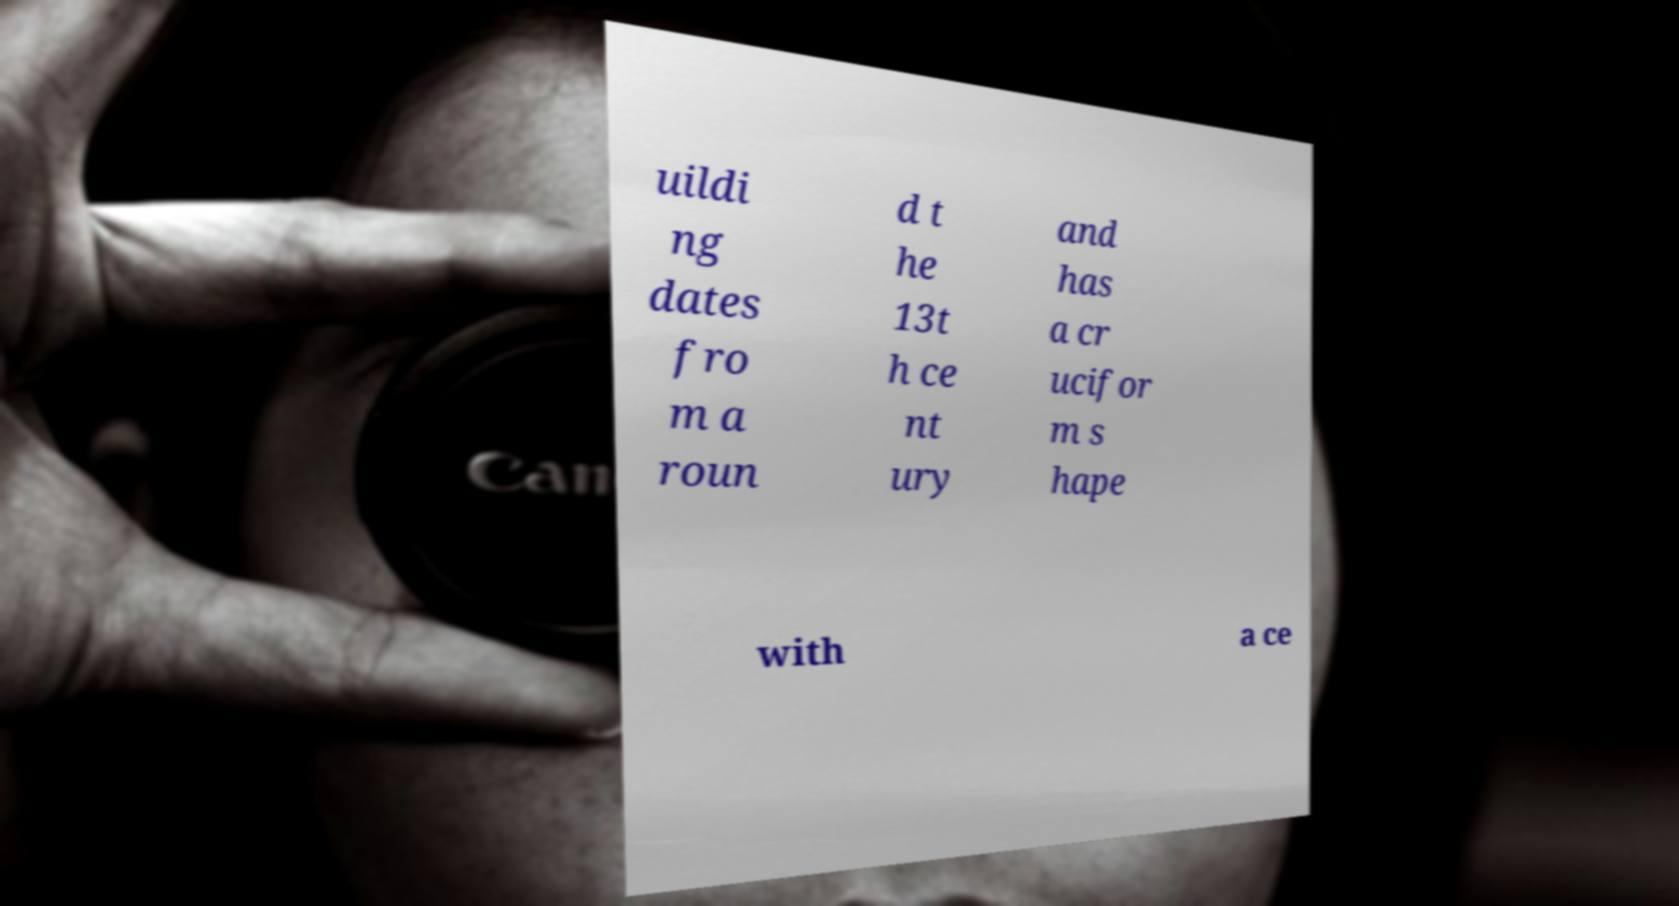Could you extract and type out the text from this image? uildi ng dates fro m a roun d t he 13t h ce nt ury and has a cr ucifor m s hape with a ce 